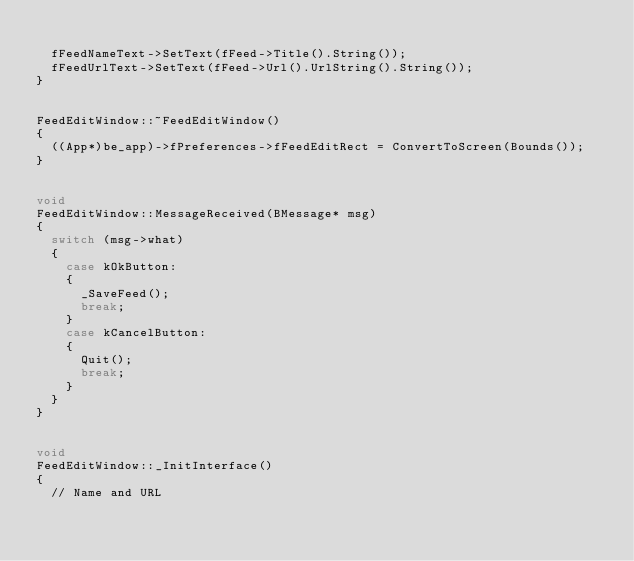<code> <loc_0><loc_0><loc_500><loc_500><_C++_>
	fFeedNameText->SetText(fFeed->Title().String());
	fFeedUrlText->SetText(fFeed->Url().UrlString().String());
}


FeedEditWindow::~FeedEditWindow()
{
	((App*)be_app)->fPreferences->fFeedEditRect = ConvertToScreen(Bounds());
}


void
FeedEditWindow::MessageReceived(BMessage* msg)
{
	switch (msg->what)
	{
		case kOkButton:
		{
			_SaveFeed();
			break;
		}
		case kCancelButton:
		{
			Quit();
			break;
		}
	}
}


void
FeedEditWindow::_InitInterface()
{
	// Name and URL</code> 